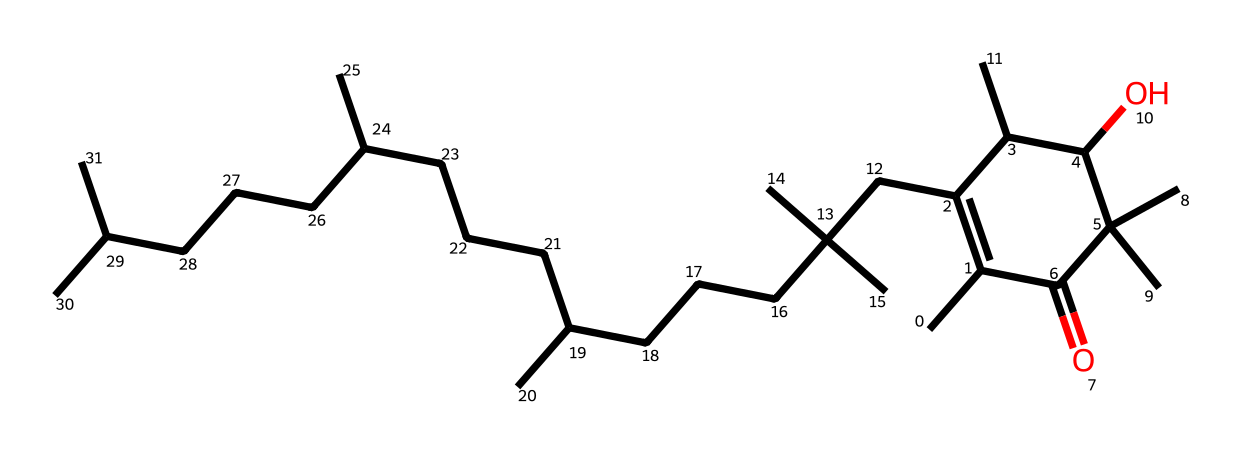What is the main functional group present in vitamin E? The SMILES structure shows a hydroxy group (OH), indicating the presence of an alcohol functional group, which is characteristic of vitamin E, specifically tocopherol.
Answer: hydroxy group How many carbon atoms are in the vitamin E structure? By analyzing the structure, I can count the number of carbon atoms, as each carbon is typically represented in the SMILES notation. There are 21 carbon atoms present in this structure.
Answer: 21 What type of molecule is vitamin E classified as? Vitamin E is classified as a fat-soluble vitamin and, more specifically, it is a member of tocopherols, which are organic compounds. The structure primarily consists of hydrocarbon chains and an alcohol group.
Answer: tocopherol What is the total number of hydrogen atoms in the molecular structure? The total number of hydrogens can be deduced from the carbon and functional groups shown in the structure. For this compound, there are 46 hydrogen atoms associated with the 21 carbons in the SMILES representation.
Answer: 46 How does vitamin E potentially help preserve technological equipment? Vitamin E acts as an antioxidant, which can help prevent oxidative damage to materials used in technological equipment, thus extending their lifespan and effectiveness.
Answer: antioxidant Which position in the vitamin E structure contributes to its antioxidant properties? The hydroxyl group (OH) attached to the aromatic ring plays a critical role in scavenging free radicals, which is a key feature of its antioxidant properties.
Answer: hydroxyl group 